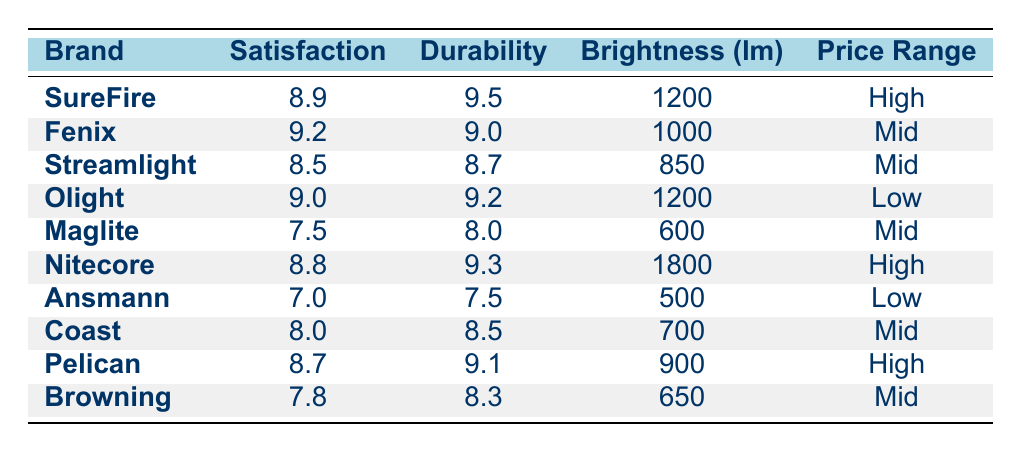What brand has the highest customer satisfaction rating? Looking through the table, I see that Fenix has the highest customer satisfaction rating of 9.2.
Answer: Fenix What is the durability score of Streamlight? According to the table, Streamlight has a durability score of 8.7.
Answer: 8.7 Which brand offers the brightest flashlight? In the table, Nitecore has the highest brightness level at 1800 lumens.
Answer: Nitecore What is the average customer satisfaction rating for brands in the low price range? The customer satisfaction ratings for the low price brands (Olight and Ansmann) are 9.0 and 7.0 respectively. The average is (9.0 + 7.0) / 2 = 8.0.
Answer: 8.0 Is it true that Maglite has a customer satisfaction rating below 8.0? Yes, Maglite's customer satisfaction rating is 7.5, which is below 8.0.
Answer: Yes Which brand has a higher durability score, SureFire or Nitecore? SureFire has a durability score of 9.5 and Nitecore has a score of 9.3. Since 9.5 is greater than 9.3, SureFire has a higher durability score.
Answer: SureFire How many brands have a customer satisfaction rating of 8.7 or higher? The brands with a customer satisfaction rating of 8.7 or higher are Fenix (9.2), Olight (9.0), Pelican (8.7), SureFire (8.9), and Nitecore (8.8). This totals to 5 brands.
Answer: 5 Which flashlight brand from the mid price range has the highest brightness level? The mid price brands are Fenix, Streamlight, Maglite, Coast, and Browning. Among them, Fenix has a brightness level of 1000 lumens, Streamlight has 850, Maglite has 600, Coast has 700, and Browning has 650. Therefore, Fenix has the highest brightness level in the mid price range.
Answer: Fenix Does Coast have a customer satisfaction rating that is above average for all brands? To find the average customer satisfaction rating, I calculate the average of all ratings: (8.9 + 9.2 + 8.5 + 9.0 + 7.5 + 8.8 + 7.0 + 8.0 + 8.7 + 7.8) / 10 = 8.57. Coast's rating is 8.0, which is below 8.57.
Answer: No 